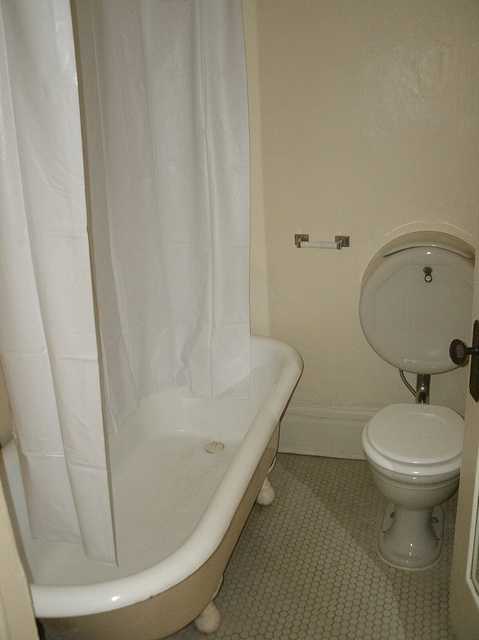Describe the objects in this image and their specific colors. I can see a toilet in gray and darkgray tones in this image. 